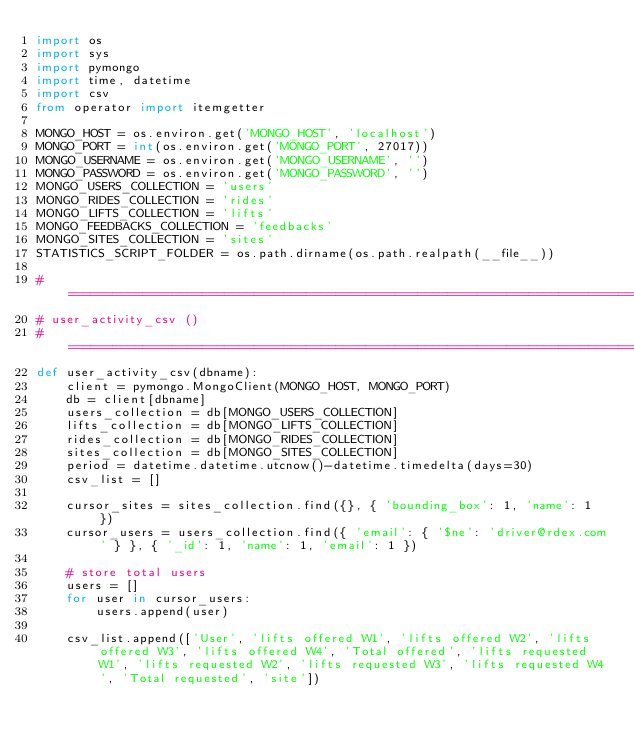<code> <loc_0><loc_0><loc_500><loc_500><_Python_>import os
import sys
import pymongo
import time, datetime
import csv
from operator import itemgetter

MONGO_HOST = os.environ.get('MONGO_HOST', 'localhost')
MONGO_PORT = int(os.environ.get('MONGO_PORT', 27017))
MONGO_USERNAME = os.environ.get('MONGO_USERNAME', '')
MONGO_PASSWORD = os.environ.get('MONGO_PASSWORD', '')
MONGO_USERS_COLLECTION = 'users'
MONGO_RIDES_COLLECTION = 'rides'
MONGO_LIFTS_COLLECTION = 'lifts'
MONGO_FEEDBACKS_COLLECTION = 'feedbacks'
MONGO_SITES_COLLECTION = 'sites'
STATISTICS_SCRIPT_FOLDER = os.path.dirname(os.path.realpath(__file__))

#===============================================================================
# user_activity_csv ()
#===============================================================================
def user_activity_csv(dbname):
    client = pymongo.MongoClient(MONGO_HOST, MONGO_PORT)
    db = client[dbname]
    users_collection = db[MONGO_USERS_COLLECTION]
    lifts_collection = db[MONGO_LIFTS_COLLECTION]
    rides_collection = db[MONGO_RIDES_COLLECTION]
    sites_collection = db[MONGO_SITES_COLLECTION]
    period = datetime.datetime.utcnow()-datetime.timedelta(days=30)
    csv_list = []

    cursor_sites = sites_collection.find({}, { 'bounding_box': 1, 'name': 1 })
    cursor_users = users_collection.find({ 'email': { '$ne': 'driver@rdex.com' } }, { '_id': 1, 'name': 1, 'email': 1 })

    # store total users
    users = []
    for user in cursor_users:
        users.append(user)

    csv_list.append(['User', 'lifts offered W1', 'lifts offered W2', 'lifts offered W3', 'lifts offered W4', 'Total offered', 'lifts requested W1', 'lifts requested W2', 'lifts requested W3', 'lifts requested W4', 'Total requested', 'site'])
</code> 